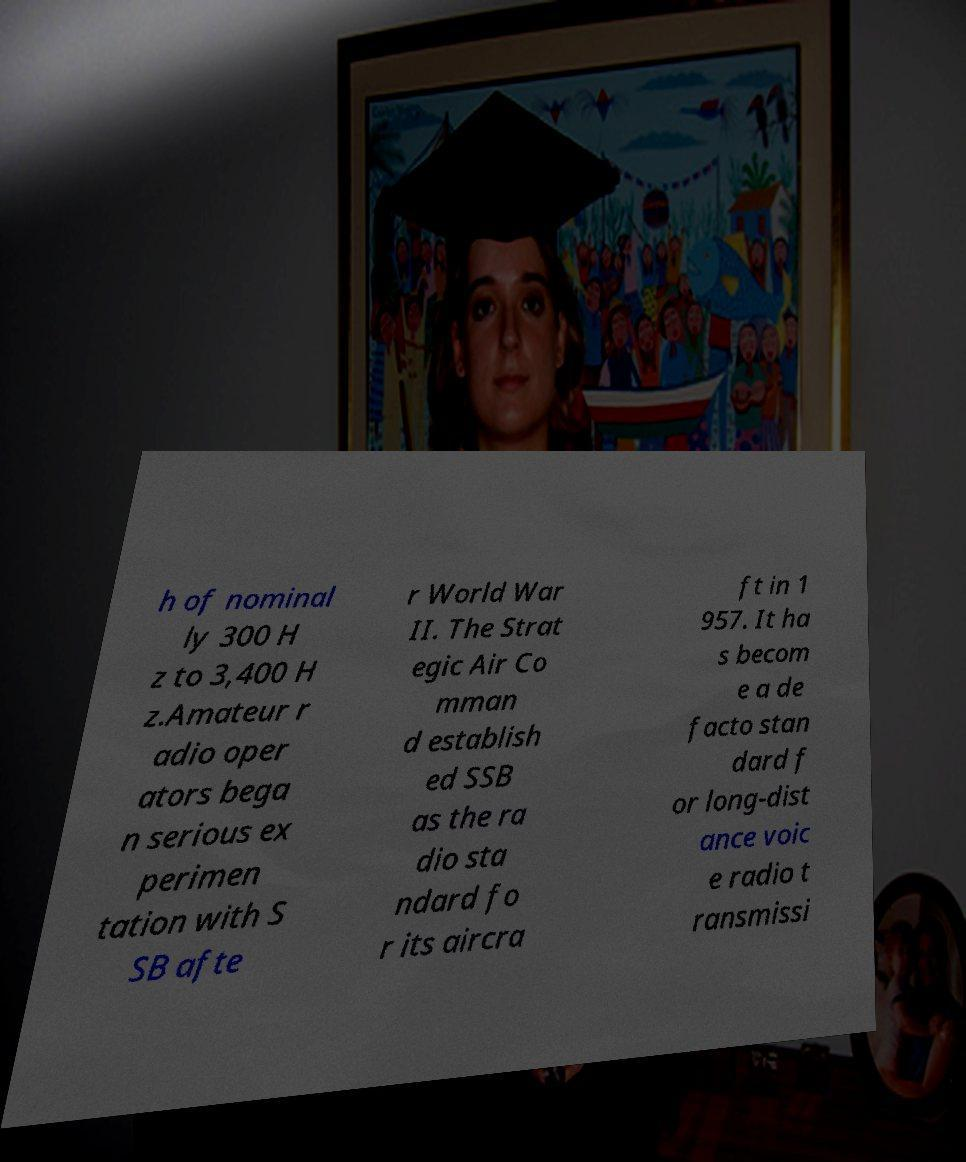There's text embedded in this image that I need extracted. Can you transcribe it verbatim? h of nominal ly 300 H z to 3,400 H z.Amateur r adio oper ators bega n serious ex perimen tation with S SB afte r World War II. The Strat egic Air Co mman d establish ed SSB as the ra dio sta ndard fo r its aircra ft in 1 957. It ha s becom e a de facto stan dard f or long-dist ance voic e radio t ransmissi 